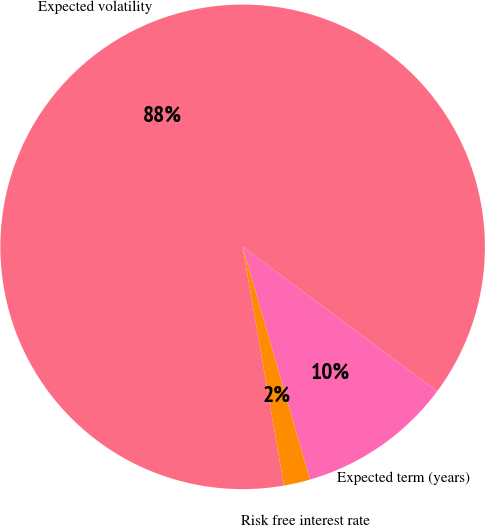<chart> <loc_0><loc_0><loc_500><loc_500><pie_chart><fcel>Expected volatility<fcel>Expected term (years)<fcel>Risk free interest rate<nl><fcel>87.89%<fcel>10.36%<fcel>1.75%<nl></chart> 